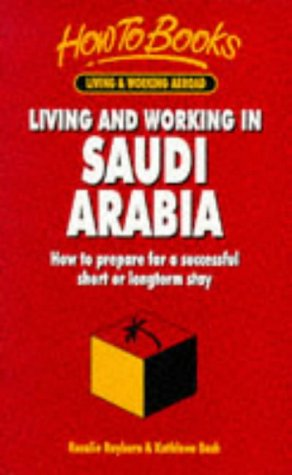Can the practical advice in this book apply to both expatriates and business travelers? Yes, the book offers practical advice suitable for expatriates planning a longer stay and business travelers visiting Saudi Arabia for shorter periods. What tips does the book provide about cultural adaptation? It provides tips on understanding and respecting local customs, dressing appropriately, and communicating effectively with Saudi nationals, which are essential for cultural adaptation. 